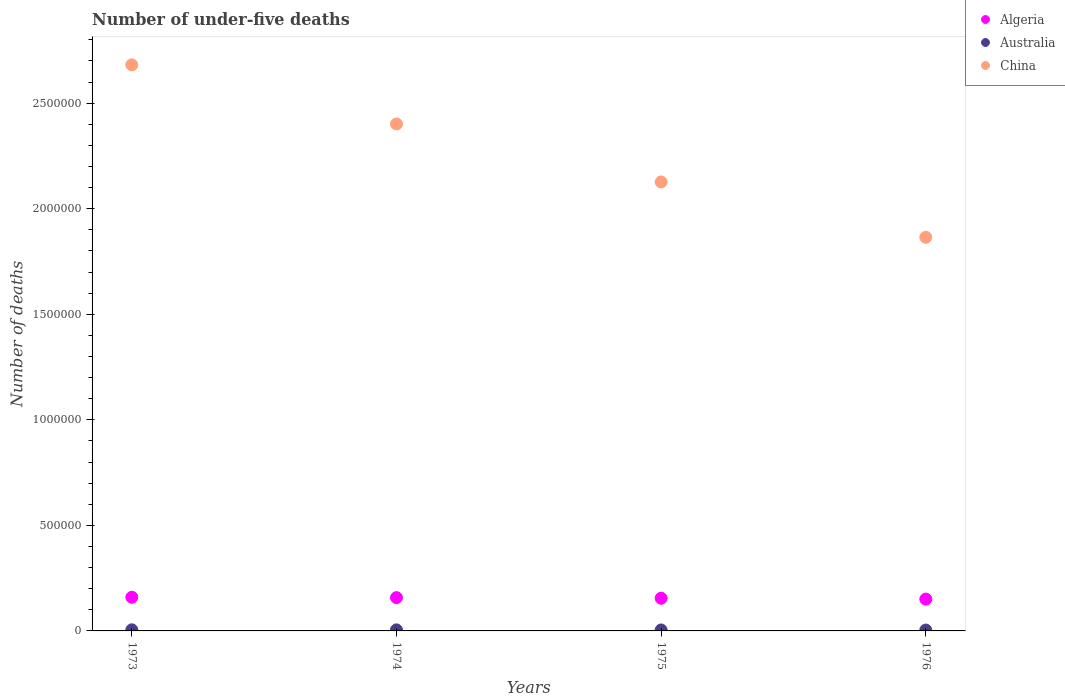Is the number of dotlines equal to the number of legend labels?
Your answer should be very brief. Yes. What is the number of under-five deaths in Australia in 1975?
Offer a terse response. 4606. Across all years, what is the maximum number of under-five deaths in Australia?
Provide a short and direct response. 5222. Across all years, what is the minimum number of under-five deaths in China?
Provide a succinct answer. 1.86e+06. In which year was the number of under-five deaths in China maximum?
Make the answer very short. 1973. In which year was the number of under-five deaths in Australia minimum?
Make the answer very short. 1976. What is the total number of under-five deaths in Algeria in the graph?
Make the answer very short. 6.23e+05. What is the difference between the number of under-five deaths in Australia in 1973 and that in 1975?
Your answer should be compact. 616. What is the difference between the number of under-five deaths in Algeria in 1973 and the number of under-five deaths in Australia in 1974?
Ensure brevity in your answer.  1.55e+05. What is the average number of under-five deaths in China per year?
Offer a very short reply. 2.27e+06. In the year 1973, what is the difference between the number of under-five deaths in Australia and number of under-five deaths in Algeria?
Your answer should be very brief. -1.54e+05. In how many years, is the number of under-five deaths in Algeria greater than 2600000?
Give a very brief answer. 0. What is the ratio of the number of under-five deaths in Australia in 1973 to that in 1975?
Your response must be concise. 1.13. Is the difference between the number of under-five deaths in Australia in 1973 and 1974 greater than the difference between the number of under-five deaths in Algeria in 1973 and 1974?
Provide a succinct answer. No. What is the difference between the highest and the second highest number of under-five deaths in Australia?
Keep it short and to the point. 239. What is the difference between the highest and the lowest number of under-five deaths in China?
Your answer should be compact. 8.17e+05. In how many years, is the number of under-five deaths in Australia greater than the average number of under-five deaths in Australia taken over all years?
Give a very brief answer. 2. Is it the case that in every year, the sum of the number of under-five deaths in Australia and number of under-five deaths in Algeria  is greater than the number of under-five deaths in China?
Make the answer very short. No. Is the number of under-five deaths in Australia strictly greater than the number of under-five deaths in Algeria over the years?
Offer a terse response. No. Is the number of under-five deaths in China strictly less than the number of under-five deaths in Australia over the years?
Give a very brief answer. No. How many years are there in the graph?
Offer a very short reply. 4. Does the graph contain any zero values?
Offer a very short reply. No. How many legend labels are there?
Keep it short and to the point. 3. How are the legend labels stacked?
Make the answer very short. Vertical. What is the title of the graph?
Your answer should be very brief. Number of under-five deaths. Does "Djibouti" appear as one of the legend labels in the graph?
Offer a terse response. No. What is the label or title of the X-axis?
Offer a very short reply. Years. What is the label or title of the Y-axis?
Your answer should be compact. Number of deaths. What is the Number of deaths of Algeria in 1973?
Your answer should be compact. 1.60e+05. What is the Number of deaths of Australia in 1973?
Your answer should be very brief. 5222. What is the Number of deaths of China in 1973?
Your response must be concise. 2.68e+06. What is the Number of deaths in Algeria in 1974?
Your answer should be compact. 1.58e+05. What is the Number of deaths in Australia in 1974?
Offer a terse response. 4983. What is the Number of deaths of China in 1974?
Make the answer very short. 2.40e+06. What is the Number of deaths in Algeria in 1975?
Keep it short and to the point. 1.55e+05. What is the Number of deaths in Australia in 1975?
Provide a short and direct response. 4606. What is the Number of deaths of China in 1975?
Make the answer very short. 2.13e+06. What is the Number of deaths of Algeria in 1976?
Your response must be concise. 1.51e+05. What is the Number of deaths in Australia in 1976?
Your answer should be very brief. 4154. What is the Number of deaths in China in 1976?
Keep it short and to the point. 1.86e+06. Across all years, what is the maximum Number of deaths in Algeria?
Make the answer very short. 1.60e+05. Across all years, what is the maximum Number of deaths in Australia?
Offer a terse response. 5222. Across all years, what is the maximum Number of deaths of China?
Your response must be concise. 2.68e+06. Across all years, what is the minimum Number of deaths in Algeria?
Keep it short and to the point. 1.51e+05. Across all years, what is the minimum Number of deaths in Australia?
Provide a short and direct response. 4154. Across all years, what is the minimum Number of deaths in China?
Offer a terse response. 1.86e+06. What is the total Number of deaths in Algeria in the graph?
Keep it short and to the point. 6.23e+05. What is the total Number of deaths in Australia in the graph?
Ensure brevity in your answer.  1.90e+04. What is the total Number of deaths of China in the graph?
Give a very brief answer. 9.07e+06. What is the difference between the Number of deaths of Algeria in 1973 and that in 1974?
Your answer should be compact. 1850. What is the difference between the Number of deaths of Australia in 1973 and that in 1974?
Your response must be concise. 239. What is the difference between the Number of deaths of China in 1973 and that in 1974?
Offer a very short reply. 2.80e+05. What is the difference between the Number of deaths in Algeria in 1973 and that in 1975?
Provide a short and direct response. 4804. What is the difference between the Number of deaths of Australia in 1973 and that in 1975?
Keep it short and to the point. 616. What is the difference between the Number of deaths in China in 1973 and that in 1975?
Your response must be concise. 5.55e+05. What is the difference between the Number of deaths of Algeria in 1973 and that in 1976?
Keep it short and to the point. 8794. What is the difference between the Number of deaths in Australia in 1973 and that in 1976?
Provide a short and direct response. 1068. What is the difference between the Number of deaths in China in 1973 and that in 1976?
Your response must be concise. 8.17e+05. What is the difference between the Number of deaths of Algeria in 1974 and that in 1975?
Offer a terse response. 2954. What is the difference between the Number of deaths in Australia in 1974 and that in 1975?
Offer a terse response. 377. What is the difference between the Number of deaths in China in 1974 and that in 1975?
Your response must be concise. 2.75e+05. What is the difference between the Number of deaths of Algeria in 1974 and that in 1976?
Your answer should be very brief. 6944. What is the difference between the Number of deaths of Australia in 1974 and that in 1976?
Offer a very short reply. 829. What is the difference between the Number of deaths of China in 1974 and that in 1976?
Make the answer very short. 5.37e+05. What is the difference between the Number of deaths in Algeria in 1975 and that in 1976?
Provide a short and direct response. 3990. What is the difference between the Number of deaths of Australia in 1975 and that in 1976?
Make the answer very short. 452. What is the difference between the Number of deaths in China in 1975 and that in 1976?
Offer a terse response. 2.62e+05. What is the difference between the Number of deaths of Algeria in 1973 and the Number of deaths of Australia in 1974?
Provide a succinct answer. 1.55e+05. What is the difference between the Number of deaths in Algeria in 1973 and the Number of deaths in China in 1974?
Make the answer very short. -2.24e+06. What is the difference between the Number of deaths in Australia in 1973 and the Number of deaths in China in 1974?
Provide a succinct answer. -2.40e+06. What is the difference between the Number of deaths in Algeria in 1973 and the Number of deaths in Australia in 1975?
Provide a short and direct response. 1.55e+05. What is the difference between the Number of deaths in Algeria in 1973 and the Number of deaths in China in 1975?
Keep it short and to the point. -1.97e+06. What is the difference between the Number of deaths in Australia in 1973 and the Number of deaths in China in 1975?
Your answer should be very brief. -2.12e+06. What is the difference between the Number of deaths of Algeria in 1973 and the Number of deaths of Australia in 1976?
Provide a short and direct response. 1.55e+05. What is the difference between the Number of deaths of Algeria in 1973 and the Number of deaths of China in 1976?
Ensure brevity in your answer.  -1.71e+06. What is the difference between the Number of deaths of Australia in 1973 and the Number of deaths of China in 1976?
Offer a very short reply. -1.86e+06. What is the difference between the Number of deaths of Algeria in 1974 and the Number of deaths of Australia in 1975?
Provide a succinct answer. 1.53e+05. What is the difference between the Number of deaths in Algeria in 1974 and the Number of deaths in China in 1975?
Your answer should be compact. -1.97e+06. What is the difference between the Number of deaths in Australia in 1974 and the Number of deaths in China in 1975?
Provide a succinct answer. -2.12e+06. What is the difference between the Number of deaths of Algeria in 1974 and the Number of deaths of Australia in 1976?
Provide a succinct answer. 1.54e+05. What is the difference between the Number of deaths of Algeria in 1974 and the Number of deaths of China in 1976?
Provide a succinct answer. -1.71e+06. What is the difference between the Number of deaths of Australia in 1974 and the Number of deaths of China in 1976?
Your answer should be very brief. -1.86e+06. What is the difference between the Number of deaths in Algeria in 1975 and the Number of deaths in Australia in 1976?
Keep it short and to the point. 1.51e+05. What is the difference between the Number of deaths of Algeria in 1975 and the Number of deaths of China in 1976?
Offer a terse response. -1.71e+06. What is the difference between the Number of deaths in Australia in 1975 and the Number of deaths in China in 1976?
Provide a short and direct response. -1.86e+06. What is the average Number of deaths of Algeria per year?
Your response must be concise. 1.56e+05. What is the average Number of deaths in Australia per year?
Give a very brief answer. 4741.25. What is the average Number of deaths in China per year?
Offer a terse response. 2.27e+06. In the year 1973, what is the difference between the Number of deaths in Algeria and Number of deaths in Australia?
Offer a terse response. 1.54e+05. In the year 1973, what is the difference between the Number of deaths of Algeria and Number of deaths of China?
Give a very brief answer. -2.52e+06. In the year 1973, what is the difference between the Number of deaths in Australia and Number of deaths in China?
Offer a very short reply. -2.68e+06. In the year 1974, what is the difference between the Number of deaths of Algeria and Number of deaths of Australia?
Offer a terse response. 1.53e+05. In the year 1974, what is the difference between the Number of deaths of Algeria and Number of deaths of China?
Provide a short and direct response. -2.24e+06. In the year 1974, what is the difference between the Number of deaths of Australia and Number of deaths of China?
Your answer should be very brief. -2.40e+06. In the year 1975, what is the difference between the Number of deaths of Algeria and Number of deaths of Australia?
Your answer should be compact. 1.50e+05. In the year 1975, what is the difference between the Number of deaths in Algeria and Number of deaths in China?
Your response must be concise. -1.97e+06. In the year 1975, what is the difference between the Number of deaths of Australia and Number of deaths of China?
Offer a very short reply. -2.12e+06. In the year 1976, what is the difference between the Number of deaths in Algeria and Number of deaths in Australia?
Provide a short and direct response. 1.47e+05. In the year 1976, what is the difference between the Number of deaths of Algeria and Number of deaths of China?
Ensure brevity in your answer.  -1.71e+06. In the year 1976, what is the difference between the Number of deaths of Australia and Number of deaths of China?
Give a very brief answer. -1.86e+06. What is the ratio of the Number of deaths of Algeria in 1973 to that in 1974?
Your answer should be compact. 1.01. What is the ratio of the Number of deaths of Australia in 1973 to that in 1974?
Provide a succinct answer. 1.05. What is the ratio of the Number of deaths in China in 1973 to that in 1974?
Offer a very short reply. 1.12. What is the ratio of the Number of deaths in Algeria in 1973 to that in 1975?
Your answer should be compact. 1.03. What is the ratio of the Number of deaths in Australia in 1973 to that in 1975?
Your response must be concise. 1.13. What is the ratio of the Number of deaths in China in 1973 to that in 1975?
Your response must be concise. 1.26. What is the ratio of the Number of deaths of Algeria in 1973 to that in 1976?
Provide a succinct answer. 1.06. What is the ratio of the Number of deaths of Australia in 1973 to that in 1976?
Make the answer very short. 1.26. What is the ratio of the Number of deaths in China in 1973 to that in 1976?
Offer a terse response. 1.44. What is the ratio of the Number of deaths of Algeria in 1974 to that in 1975?
Make the answer very short. 1.02. What is the ratio of the Number of deaths of Australia in 1974 to that in 1975?
Your response must be concise. 1.08. What is the ratio of the Number of deaths of China in 1974 to that in 1975?
Your answer should be very brief. 1.13. What is the ratio of the Number of deaths in Algeria in 1974 to that in 1976?
Provide a short and direct response. 1.05. What is the ratio of the Number of deaths in Australia in 1974 to that in 1976?
Provide a short and direct response. 1.2. What is the ratio of the Number of deaths in China in 1974 to that in 1976?
Offer a very short reply. 1.29. What is the ratio of the Number of deaths of Algeria in 1975 to that in 1976?
Your answer should be compact. 1.03. What is the ratio of the Number of deaths in Australia in 1975 to that in 1976?
Provide a succinct answer. 1.11. What is the ratio of the Number of deaths in China in 1975 to that in 1976?
Your answer should be very brief. 1.14. What is the difference between the highest and the second highest Number of deaths of Algeria?
Ensure brevity in your answer.  1850. What is the difference between the highest and the second highest Number of deaths of Australia?
Give a very brief answer. 239. What is the difference between the highest and the second highest Number of deaths in China?
Your response must be concise. 2.80e+05. What is the difference between the highest and the lowest Number of deaths in Algeria?
Ensure brevity in your answer.  8794. What is the difference between the highest and the lowest Number of deaths in Australia?
Provide a short and direct response. 1068. What is the difference between the highest and the lowest Number of deaths in China?
Make the answer very short. 8.17e+05. 